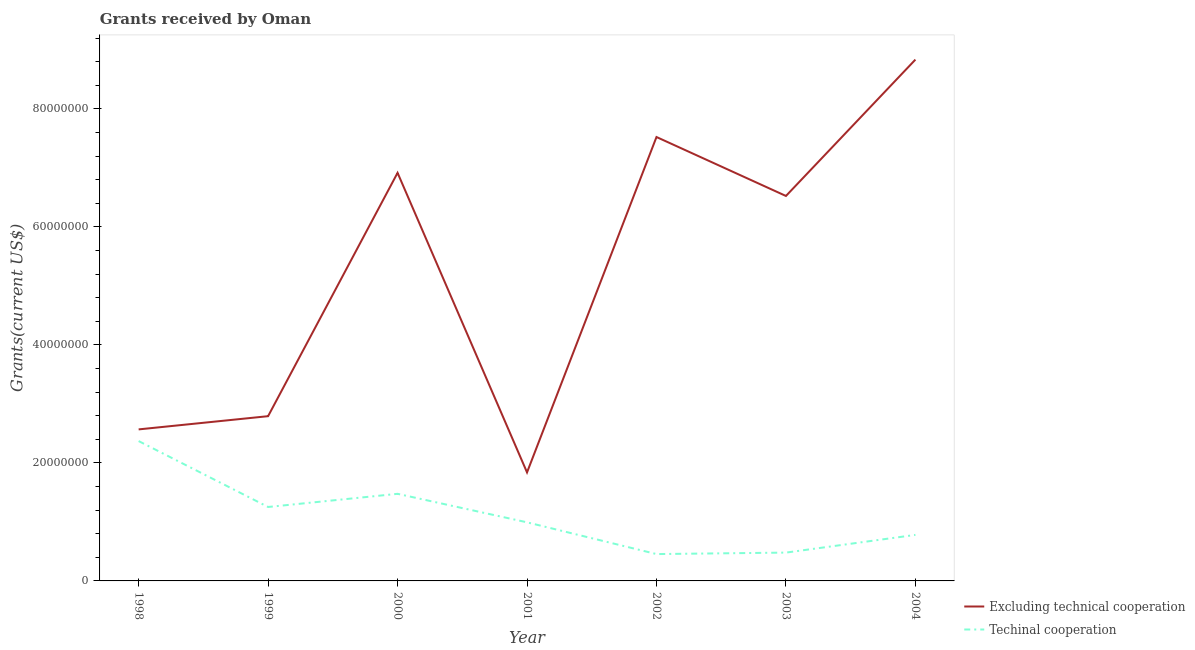What is the amount of grants received(including technical cooperation) in 2003?
Your answer should be compact. 4.80e+06. Across all years, what is the maximum amount of grants received(excluding technical cooperation)?
Keep it short and to the point. 8.84e+07. Across all years, what is the minimum amount of grants received(including technical cooperation)?
Offer a terse response. 4.55e+06. In which year was the amount of grants received(excluding technical cooperation) minimum?
Your answer should be very brief. 2001. What is the total amount of grants received(excluding technical cooperation) in the graph?
Provide a succinct answer. 3.70e+08. What is the difference between the amount of grants received(excluding technical cooperation) in 1999 and that in 2004?
Your answer should be compact. -6.04e+07. What is the difference between the amount of grants received(including technical cooperation) in 1998 and the amount of grants received(excluding technical cooperation) in 1999?
Your response must be concise. -4.22e+06. What is the average amount of grants received(excluding technical cooperation) per year?
Give a very brief answer. 5.29e+07. In the year 2003, what is the difference between the amount of grants received(including technical cooperation) and amount of grants received(excluding technical cooperation)?
Provide a succinct answer. -6.04e+07. In how many years, is the amount of grants received(including technical cooperation) greater than 48000000 US$?
Provide a succinct answer. 0. What is the ratio of the amount of grants received(including technical cooperation) in 1999 to that in 2001?
Your response must be concise. 1.26. Is the amount of grants received(including technical cooperation) in 1999 less than that in 2000?
Your response must be concise. Yes. What is the difference between the highest and the second highest amount of grants received(including technical cooperation)?
Make the answer very short. 8.94e+06. What is the difference between the highest and the lowest amount of grants received(excluding technical cooperation)?
Make the answer very short. 7.00e+07. In how many years, is the amount of grants received(including technical cooperation) greater than the average amount of grants received(including technical cooperation) taken over all years?
Ensure brevity in your answer.  3. Is the sum of the amount of grants received(excluding technical cooperation) in 1998 and 2003 greater than the maximum amount of grants received(including technical cooperation) across all years?
Your answer should be very brief. Yes. Does the amount of grants received(including technical cooperation) monotonically increase over the years?
Provide a short and direct response. No. How many lines are there?
Provide a succinct answer. 2. How many years are there in the graph?
Ensure brevity in your answer.  7. Where does the legend appear in the graph?
Your answer should be compact. Bottom right. How many legend labels are there?
Make the answer very short. 2. How are the legend labels stacked?
Offer a very short reply. Vertical. What is the title of the graph?
Make the answer very short. Grants received by Oman. Does "Non-residents" appear as one of the legend labels in the graph?
Offer a terse response. No. What is the label or title of the X-axis?
Your answer should be compact. Year. What is the label or title of the Y-axis?
Make the answer very short. Grants(current US$). What is the Grants(current US$) in Excluding technical cooperation in 1998?
Ensure brevity in your answer.  2.57e+07. What is the Grants(current US$) of Techinal cooperation in 1998?
Give a very brief answer. 2.37e+07. What is the Grants(current US$) of Excluding technical cooperation in 1999?
Ensure brevity in your answer.  2.79e+07. What is the Grants(current US$) of Techinal cooperation in 1999?
Provide a short and direct response. 1.25e+07. What is the Grants(current US$) of Excluding technical cooperation in 2000?
Offer a very short reply. 6.92e+07. What is the Grants(current US$) of Techinal cooperation in 2000?
Your answer should be very brief. 1.48e+07. What is the Grants(current US$) of Excluding technical cooperation in 2001?
Make the answer very short. 1.84e+07. What is the Grants(current US$) in Techinal cooperation in 2001?
Your answer should be very brief. 9.93e+06. What is the Grants(current US$) of Excluding technical cooperation in 2002?
Make the answer very short. 7.52e+07. What is the Grants(current US$) in Techinal cooperation in 2002?
Your answer should be very brief. 4.55e+06. What is the Grants(current US$) of Excluding technical cooperation in 2003?
Your response must be concise. 6.52e+07. What is the Grants(current US$) in Techinal cooperation in 2003?
Give a very brief answer. 4.80e+06. What is the Grants(current US$) in Excluding technical cooperation in 2004?
Your response must be concise. 8.84e+07. What is the Grants(current US$) in Techinal cooperation in 2004?
Give a very brief answer. 7.80e+06. Across all years, what is the maximum Grants(current US$) of Excluding technical cooperation?
Make the answer very short. 8.84e+07. Across all years, what is the maximum Grants(current US$) of Techinal cooperation?
Ensure brevity in your answer.  2.37e+07. Across all years, what is the minimum Grants(current US$) of Excluding technical cooperation?
Your answer should be compact. 1.84e+07. Across all years, what is the minimum Grants(current US$) in Techinal cooperation?
Give a very brief answer. 4.55e+06. What is the total Grants(current US$) of Excluding technical cooperation in the graph?
Keep it short and to the point. 3.70e+08. What is the total Grants(current US$) in Techinal cooperation in the graph?
Keep it short and to the point. 7.81e+07. What is the difference between the Grants(current US$) in Excluding technical cooperation in 1998 and that in 1999?
Make the answer very short. -2.24e+06. What is the difference between the Grants(current US$) in Techinal cooperation in 1998 and that in 1999?
Give a very brief answer. 1.12e+07. What is the difference between the Grants(current US$) of Excluding technical cooperation in 1998 and that in 2000?
Your answer should be very brief. -4.35e+07. What is the difference between the Grants(current US$) of Techinal cooperation in 1998 and that in 2000?
Ensure brevity in your answer.  8.94e+06. What is the difference between the Grants(current US$) of Excluding technical cooperation in 1998 and that in 2001?
Give a very brief answer. 7.29e+06. What is the difference between the Grants(current US$) in Techinal cooperation in 1998 and that in 2001?
Make the answer very short. 1.38e+07. What is the difference between the Grants(current US$) of Excluding technical cooperation in 1998 and that in 2002?
Provide a succinct answer. -4.96e+07. What is the difference between the Grants(current US$) in Techinal cooperation in 1998 and that in 2002?
Your answer should be compact. 1.92e+07. What is the difference between the Grants(current US$) of Excluding technical cooperation in 1998 and that in 2003?
Give a very brief answer. -3.96e+07. What is the difference between the Grants(current US$) of Techinal cooperation in 1998 and that in 2003?
Give a very brief answer. 1.89e+07. What is the difference between the Grants(current US$) in Excluding technical cooperation in 1998 and that in 2004?
Your response must be concise. -6.27e+07. What is the difference between the Grants(current US$) in Techinal cooperation in 1998 and that in 2004?
Provide a succinct answer. 1.59e+07. What is the difference between the Grants(current US$) of Excluding technical cooperation in 1999 and that in 2000?
Ensure brevity in your answer.  -4.12e+07. What is the difference between the Grants(current US$) in Techinal cooperation in 1999 and that in 2000?
Your response must be concise. -2.23e+06. What is the difference between the Grants(current US$) in Excluding technical cooperation in 1999 and that in 2001?
Your response must be concise. 9.53e+06. What is the difference between the Grants(current US$) of Techinal cooperation in 1999 and that in 2001?
Keep it short and to the point. 2.60e+06. What is the difference between the Grants(current US$) of Excluding technical cooperation in 1999 and that in 2002?
Provide a succinct answer. -4.73e+07. What is the difference between the Grants(current US$) of Techinal cooperation in 1999 and that in 2002?
Make the answer very short. 7.98e+06. What is the difference between the Grants(current US$) in Excluding technical cooperation in 1999 and that in 2003?
Provide a short and direct response. -3.73e+07. What is the difference between the Grants(current US$) in Techinal cooperation in 1999 and that in 2003?
Provide a succinct answer. 7.73e+06. What is the difference between the Grants(current US$) in Excluding technical cooperation in 1999 and that in 2004?
Keep it short and to the point. -6.04e+07. What is the difference between the Grants(current US$) of Techinal cooperation in 1999 and that in 2004?
Offer a terse response. 4.73e+06. What is the difference between the Grants(current US$) of Excluding technical cooperation in 2000 and that in 2001?
Ensure brevity in your answer.  5.08e+07. What is the difference between the Grants(current US$) in Techinal cooperation in 2000 and that in 2001?
Your answer should be compact. 4.83e+06. What is the difference between the Grants(current US$) of Excluding technical cooperation in 2000 and that in 2002?
Keep it short and to the point. -6.07e+06. What is the difference between the Grants(current US$) of Techinal cooperation in 2000 and that in 2002?
Your answer should be compact. 1.02e+07. What is the difference between the Grants(current US$) of Excluding technical cooperation in 2000 and that in 2003?
Offer a very short reply. 3.92e+06. What is the difference between the Grants(current US$) of Techinal cooperation in 2000 and that in 2003?
Your answer should be very brief. 9.96e+06. What is the difference between the Grants(current US$) in Excluding technical cooperation in 2000 and that in 2004?
Your answer should be very brief. -1.92e+07. What is the difference between the Grants(current US$) of Techinal cooperation in 2000 and that in 2004?
Offer a terse response. 6.96e+06. What is the difference between the Grants(current US$) of Excluding technical cooperation in 2001 and that in 2002?
Ensure brevity in your answer.  -5.68e+07. What is the difference between the Grants(current US$) in Techinal cooperation in 2001 and that in 2002?
Ensure brevity in your answer.  5.38e+06. What is the difference between the Grants(current US$) in Excluding technical cooperation in 2001 and that in 2003?
Provide a succinct answer. -4.68e+07. What is the difference between the Grants(current US$) of Techinal cooperation in 2001 and that in 2003?
Offer a terse response. 5.13e+06. What is the difference between the Grants(current US$) in Excluding technical cooperation in 2001 and that in 2004?
Keep it short and to the point. -7.00e+07. What is the difference between the Grants(current US$) of Techinal cooperation in 2001 and that in 2004?
Keep it short and to the point. 2.13e+06. What is the difference between the Grants(current US$) in Excluding technical cooperation in 2002 and that in 2003?
Provide a short and direct response. 9.99e+06. What is the difference between the Grants(current US$) in Techinal cooperation in 2002 and that in 2003?
Your answer should be very brief. -2.50e+05. What is the difference between the Grants(current US$) in Excluding technical cooperation in 2002 and that in 2004?
Provide a succinct answer. -1.31e+07. What is the difference between the Grants(current US$) of Techinal cooperation in 2002 and that in 2004?
Provide a short and direct response. -3.25e+06. What is the difference between the Grants(current US$) of Excluding technical cooperation in 2003 and that in 2004?
Make the answer very short. -2.31e+07. What is the difference between the Grants(current US$) in Excluding technical cooperation in 1998 and the Grants(current US$) in Techinal cooperation in 1999?
Offer a very short reply. 1.32e+07. What is the difference between the Grants(current US$) in Excluding technical cooperation in 1998 and the Grants(current US$) in Techinal cooperation in 2000?
Offer a terse response. 1.09e+07. What is the difference between the Grants(current US$) in Excluding technical cooperation in 1998 and the Grants(current US$) in Techinal cooperation in 2001?
Offer a terse response. 1.58e+07. What is the difference between the Grants(current US$) of Excluding technical cooperation in 1998 and the Grants(current US$) of Techinal cooperation in 2002?
Your answer should be compact. 2.11e+07. What is the difference between the Grants(current US$) of Excluding technical cooperation in 1998 and the Grants(current US$) of Techinal cooperation in 2003?
Make the answer very short. 2.09e+07. What is the difference between the Grants(current US$) in Excluding technical cooperation in 1998 and the Grants(current US$) in Techinal cooperation in 2004?
Your answer should be very brief. 1.79e+07. What is the difference between the Grants(current US$) of Excluding technical cooperation in 1999 and the Grants(current US$) of Techinal cooperation in 2000?
Provide a short and direct response. 1.32e+07. What is the difference between the Grants(current US$) of Excluding technical cooperation in 1999 and the Grants(current US$) of Techinal cooperation in 2001?
Offer a terse response. 1.80e+07. What is the difference between the Grants(current US$) in Excluding technical cooperation in 1999 and the Grants(current US$) in Techinal cooperation in 2002?
Make the answer very short. 2.34e+07. What is the difference between the Grants(current US$) in Excluding technical cooperation in 1999 and the Grants(current US$) in Techinal cooperation in 2003?
Your response must be concise. 2.31e+07. What is the difference between the Grants(current US$) of Excluding technical cooperation in 1999 and the Grants(current US$) of Techinal cooperation in 2004?
Ensure brevity in your answer.  2.01e+07. What is the difference between the Grants(current US$) of Excluding technical cooperation in 2000 and the Grants(current US$) of Techinal cooperation in 2001?
Give a very brief answer. 5.92e+07. What is the difference between the Grants(current US$) in Excluding technical cooperation in 2000 and the Grants(current US$) in Techinal cooperation in 2002?
Your answer should be compact. 6.46e+07. What is the difference between the Grants(current US$) of Excluding technical cooperation in 2000 and the Grants(current US$) of Techinal cooperation in 2003?
Make the answer very short. 6.44e+07. What is the difference between the Grants(current US$) in Excluding technical cooperation in 2000 and the Grants(current US$) in Techinal cooperation in 2004?
Your answer should be very brief. 6.14e+07. What is the difference between the Grants(current US$) in Excluding technical cooperation in 2001 and the Grants(current US$) in Techinal cooperation in 2002?
Your answer should be compact. 1.38e+07. What is the difference between the Grants(current US$) of Excluding technical cooperation in 2001 and the Grants(current US$) of Techinal cooperation in 2003?
Offer a very short reply. 1.36e+07. What is the difference between the Grants(current US$) of Excluding technical cooperation in 2001 and the Grants(current US$) of Techinal cooperation in 2004?
Ensure brevity in your answer.  1.06e+07. What is the difference between the Grants(current US$) of Excluding technical cooperation in 2002 and the Grants(current US$) of Techinal cooperation in 2003?
Make the answer very short. 7.04e+07. What is the difference between the Grants(current US$) in Excluding technical cooperation in 2002 and the Grants(current US$) in Techinal cooperation in 2004?
Offer a very short reply. 6.74e+07. What is the difference between the Grants(current US$) of Excluding technical cooperation in 2003 and the Grants(current US$) of Techinal cooperation in 2004?
Give a very brief answer. 5.74e+07. What is the average Grants(current US$) of Excluding technical cooperation per year?
Your answer should be compact. 5.29e+07. What is the average Grants(current US$) of Techinal cooperation per year?
Provide a succinct answer. 1.12e+07. In the year 1998, what is the difference between the Grants(current US$) in Excluding technical cooperation and Grants(current US$) in Techinal cooperation?
Offer a terse response. 1.98e+06. In the year 1999, what is the difference between the Grants(current US$) of Excluding technical cooperation and Grants(current US$) of Techinal cooperation?
Give a very brief answer. 1.54e+07. In the year 2000, what is the difference between the Grants(current US$) in Excluding technical cooperation and Grants(current US$) in Techinal cooperation?
Provide a short and direct response. 5.44e+07. In the year 2001, what is the difference between the Grants(current US$) in Excluding technical cooperation and Grants(current US$) in Techinal cooperation?
Provide a short and direct response. 8.46e+06. In the year 2002, what is the difference between the Grants(current US$) of Excluding technical cooperation and Grants(current US$) of Techinal cooperation?
Your response must be concise. 7.07e+07. In the year 2003, what is the difference between the Grants(current US$) of Excluding technical cooperation and Grants(current US$) of Techinal cooperation?
Make the answer very short. 6.04e+07. In the year 2004, what is the difference between the Grants(current US$) of Excluding technical cooperation and Grants(current US$) of Techinal cooperation?
Give a very brief answer. 8.06e+07. What is the ratio of the Grants(current US$) in Excluding technical cooperation in 1998 to that in 1999?
Your response must be concise. 0.92. What is the ratio of the Grants(current US$) of Techinal cooperation in 1998 to that in 1999?
Give a very brief answer. 1.89. What is the ratio of the Grants(current US$) of Excluding technical cooperation in 1998 to that in 2000?
Keep it short and to the point. 0.37. What is the ratio of the Grants(current US$) in Techinal cooperation in 1998 to that in 2000?
Offer a very short reply. 1.61. What is the ratio of the Grants(current US$) of Excluding technical cooperation in 1998 to that in 2001?
Your response must be concise. 1.4. What is the ratio of the Grants(current US$) of Techinal cooperation in 1998 to that in 2001?
Offer a terse response. 2.39. What is the ratio of the Grants(current US$) of Excluding technical cooperation in 1998 to that in 2002?
Your answer should be very brief. 0.34. What is the ratio of the Grants(current US$) of Techinal cooperation in 1998 to that in 2002?
Provide a short and direct response. 5.21. What is the ratio of the Grants(current US$) of Excluding technical cooperation in 1998 to that in 2003?
Your answer should be very brief. 0.39. What is the ratio of the Grants(current US$) of Techinal cooperation in 1998 to that in 2003?
Make the answer very short. 4.94. What is the ratio of the Grants(current US$) in Excluding technical cooperation in 1998 to that in 2004?
Your answer should be compact. 0.29. What is the ratio of the Grants(current US$) of Techinal cooperation in 1998 to that in 2004?
Offer a very short reply. 3.04. What is the ratio of the Grants(current US$) in Excluding technical cooperation in 1999 to that in 2000?
Offer a very short reply. 0.4. What is the ratio of the Grants(current US$) in Techinal cooperation in 1999 to that in 2000?
Offer a terse response. 0.85. What is the ratio of the Grants(current US$) of Excluding technical cooperation in 1999 to that in 2001?
Your answer should be very brief. 1.52. What is the ratio of the Grants(current US$) in Techinal cooperation in 1999 to that in 2001?
Provide a succinct answer. 1.26. What is the ratio of the Grants(current US$) of Excluding technical cooperation in 1999 to that in 2002?
Provide a succinct answer. 0.37. What is the ratio of the Grants(current US$) of Techinal cooperation in 1999 to that in 2002?
Keep it short and to the point. 2.75. What is the ratio of the Grants(current US$) of Excluding technical cooperation in 1999 to that in 2003?
Your answer should be very brief. 0.43. What is the ratio of the Grants(current US$) in Techinal cooperation in 1999 to that in 2003?
Your answer should be very brief. 2.61. What is the ratio of the Grants(current US$) of Excluding technical cooperation in 1999 to that in 2004?
Your answer should be compact. 0.32. What is the ratio of the Grants(current US$) in Techinal cooperation in 1999 to that in 2004?
Ensure brevity in your answer.  1.61. What is the ratio of the Grants(current US$) of Excluding technical cooperation in 2000 to that in 2001?
Offer a terse response. 3.76. What is the ratio of the Grants(current US$) of Techinal cooperation in 2000 to that in 2001?
Offer a very short reply. 1.49. What is the ratio of the Grants(current US$) in Excluding technical cooperation in 2000 to that in 2002?
Offer a terse response. 0.92. What is the ratio of the Grants(current US$) of Techinal cooperation in 2000 to that in 2002?
Your answer should be very brief. 3.24. What is the ratio of the Grants(current US$) of Excluding technical cooperation in 2000 to that in 2003?
Provide a short and direct response. 1.06. What is the ratio of the Grants(current US$) in Techinal cooperation in 2000 to that in 2003?
Provide a short and direct response. 3.08. What is the ratio of the Grants(current US$) in Excluding technical cooperation in 2000 to that in 2004?
Offer a very short reply. 0.78. What is the ratio of the Grants(current US$) in Techinal cooperation in 2000 to that in 2004?
Keep it short and to the point. 1.89. What is the ratio of the Grants(current US$) of Excluding technical cooperation in 2001 to that in 2002?
Offer a very short reply. 0.24. What is the ratio of the Grants(current US$) of Techinal cooperation in 2001 to that in 2002?
Provide a succinct answer. 2.18. What is the ratio of the Grants(current US$) of Excluding technical cooperation in 2001 to that in 2003?
Provide a succinct answer. 0.28. What is the ratio of the Grants(current US$) of Techinal cooperation in 2001 to that in 2003?
Ensure brevity in your answer.  2.07. What is the ratio of the Grants(current US$) of Excluding technical cooperation in 2001 to that in 2004?
Your response must be concise. 0.21. What is the ratio of the Grants(current US$) in Techinal cooperation in 2001 to that in 2004?
Offer a very short reply. 1.27. What is the ratio of the Grants(current US$) of Excluding technical cooperation in 2002 to that in 2003?
Provide a succinct answer. 1.15. What is the ratio of the Grants(current US$) of Techinal cooperation in 2002 to that in 2003?
Keep it short and to the point. 0.95. What is the ratio of the Grants(current US$) of Excluding technical cooperation in 2002 to that in 2004?
Your response must be concise. 0.85. What is the ratio of the Grants(current US$) of Techinal cooperation in 2002 to that in 2004?
Provide a succinct answer. 0.58. What is the ratio of the Grants(current US$) of Excluding technical cooperation in 2003 to that in 2004?
Provide a short and direct response. 0.74. What is the ratio of the Grants(current US$) in Techinal cooperation in 2003 to that in 2004?
Offer a very short reply. 0.62. What is the difference between the highest and the second highest Grants(current US$) in Excluding technical cooperation?
Ensure brevity in your answer.  1.31e+07. What is the difference between the highest and the second highest Grants(current US$) of Techinal cooperation?
Offer a very short reply. 8.94e+06. What is the difference between the highest and the lowest Grants(current US$) of Excluding technical cooperation?
Keep it short and to the point. 7.00e+07. What is the difference between the highest and the lowest Grants(current US$) in Techinal cooperation?
Keep it short and to the point. 1.92e+07. 